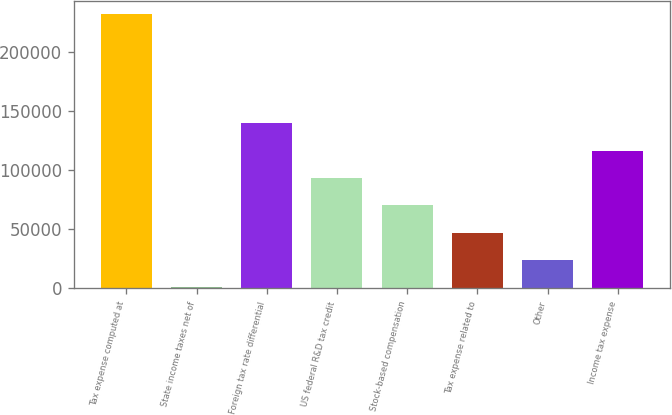<chart> <loc_0><loc_0><loc_500><loc_500><bar_chart><fcel>Tax expense computed at<fcel>State income taxes net of<fcel>Foreign tax rate differential<fcel>US federal R&D tax credit<fcel>Stock-based compensation<fcel>Tax expense related to<fcel>Other<fcel>Income tax expense<nl><fcel>231714<fcel>1048<fcel>139448<fcel>93314.4<fcel>70247.8<fcel>47181.2<fcel>24114.6<fcel>116381<nl></chart> 